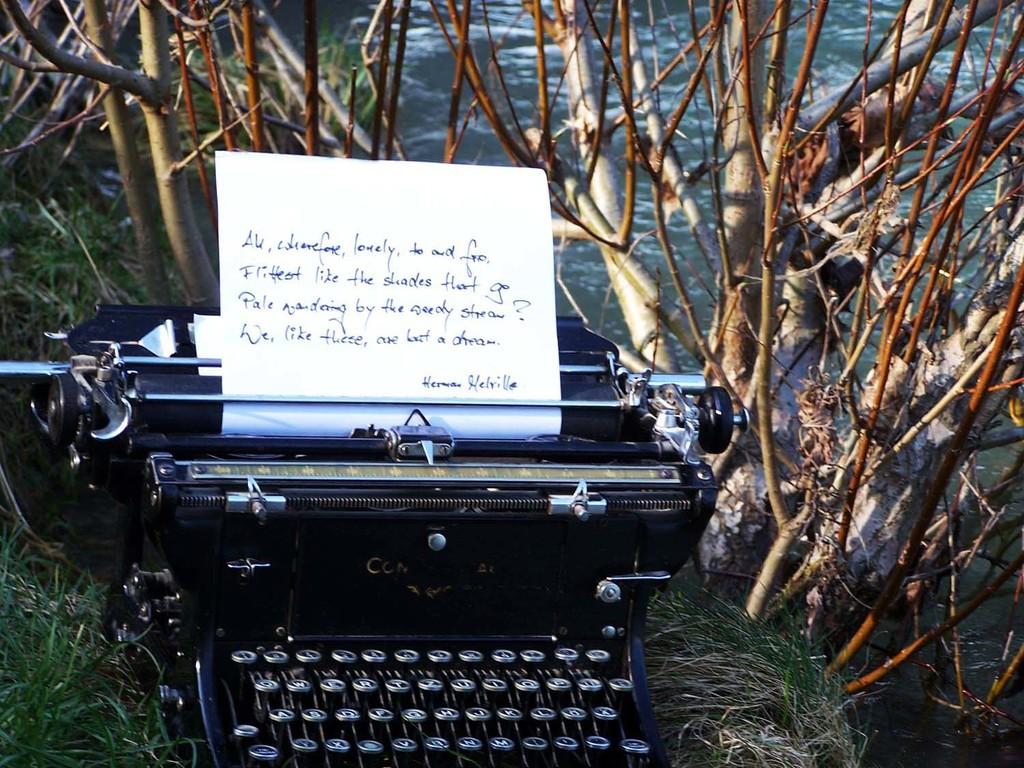Who signed this letter?
Keep it short and to the point. Herman helville. What is the first word in the letter?
Give a very brief answer. All. 